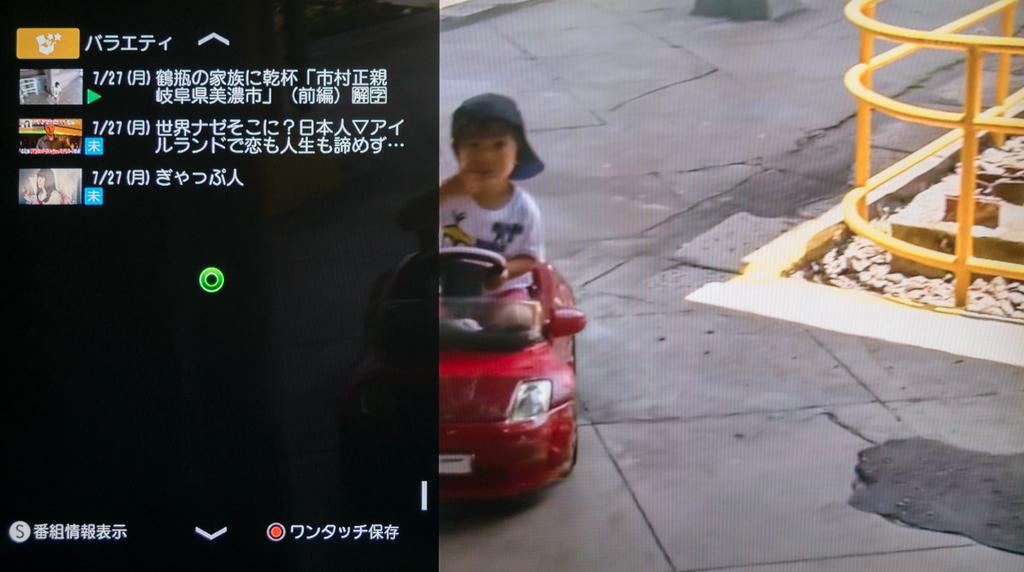What language is the text written in the image? The text is written in Chinese in the image. What is the subject of the text? The text is about videos. What is the boy in the image doing? The boy is riding a toy car in the image. What can be seen in the background of the image? There is a fence in the image. Where is the tent located in the image? There is no tent present in the image. What type of field can be seen in the image? There is no field present in the image. 